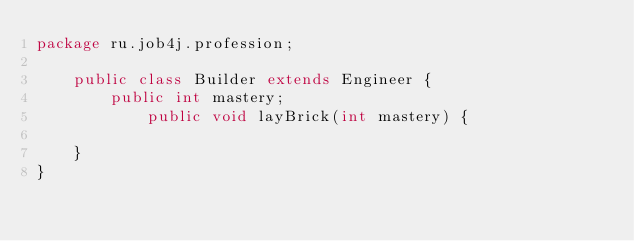Convert code to text. <code><loc_0><loc_0><loc_500><loc_500><_Java_>package ru.job4j.profession;

    public class Builder extends Engineer {
        public int mastery;
            public void layBrick(int mastery) {
                
    }        
}
</code> 